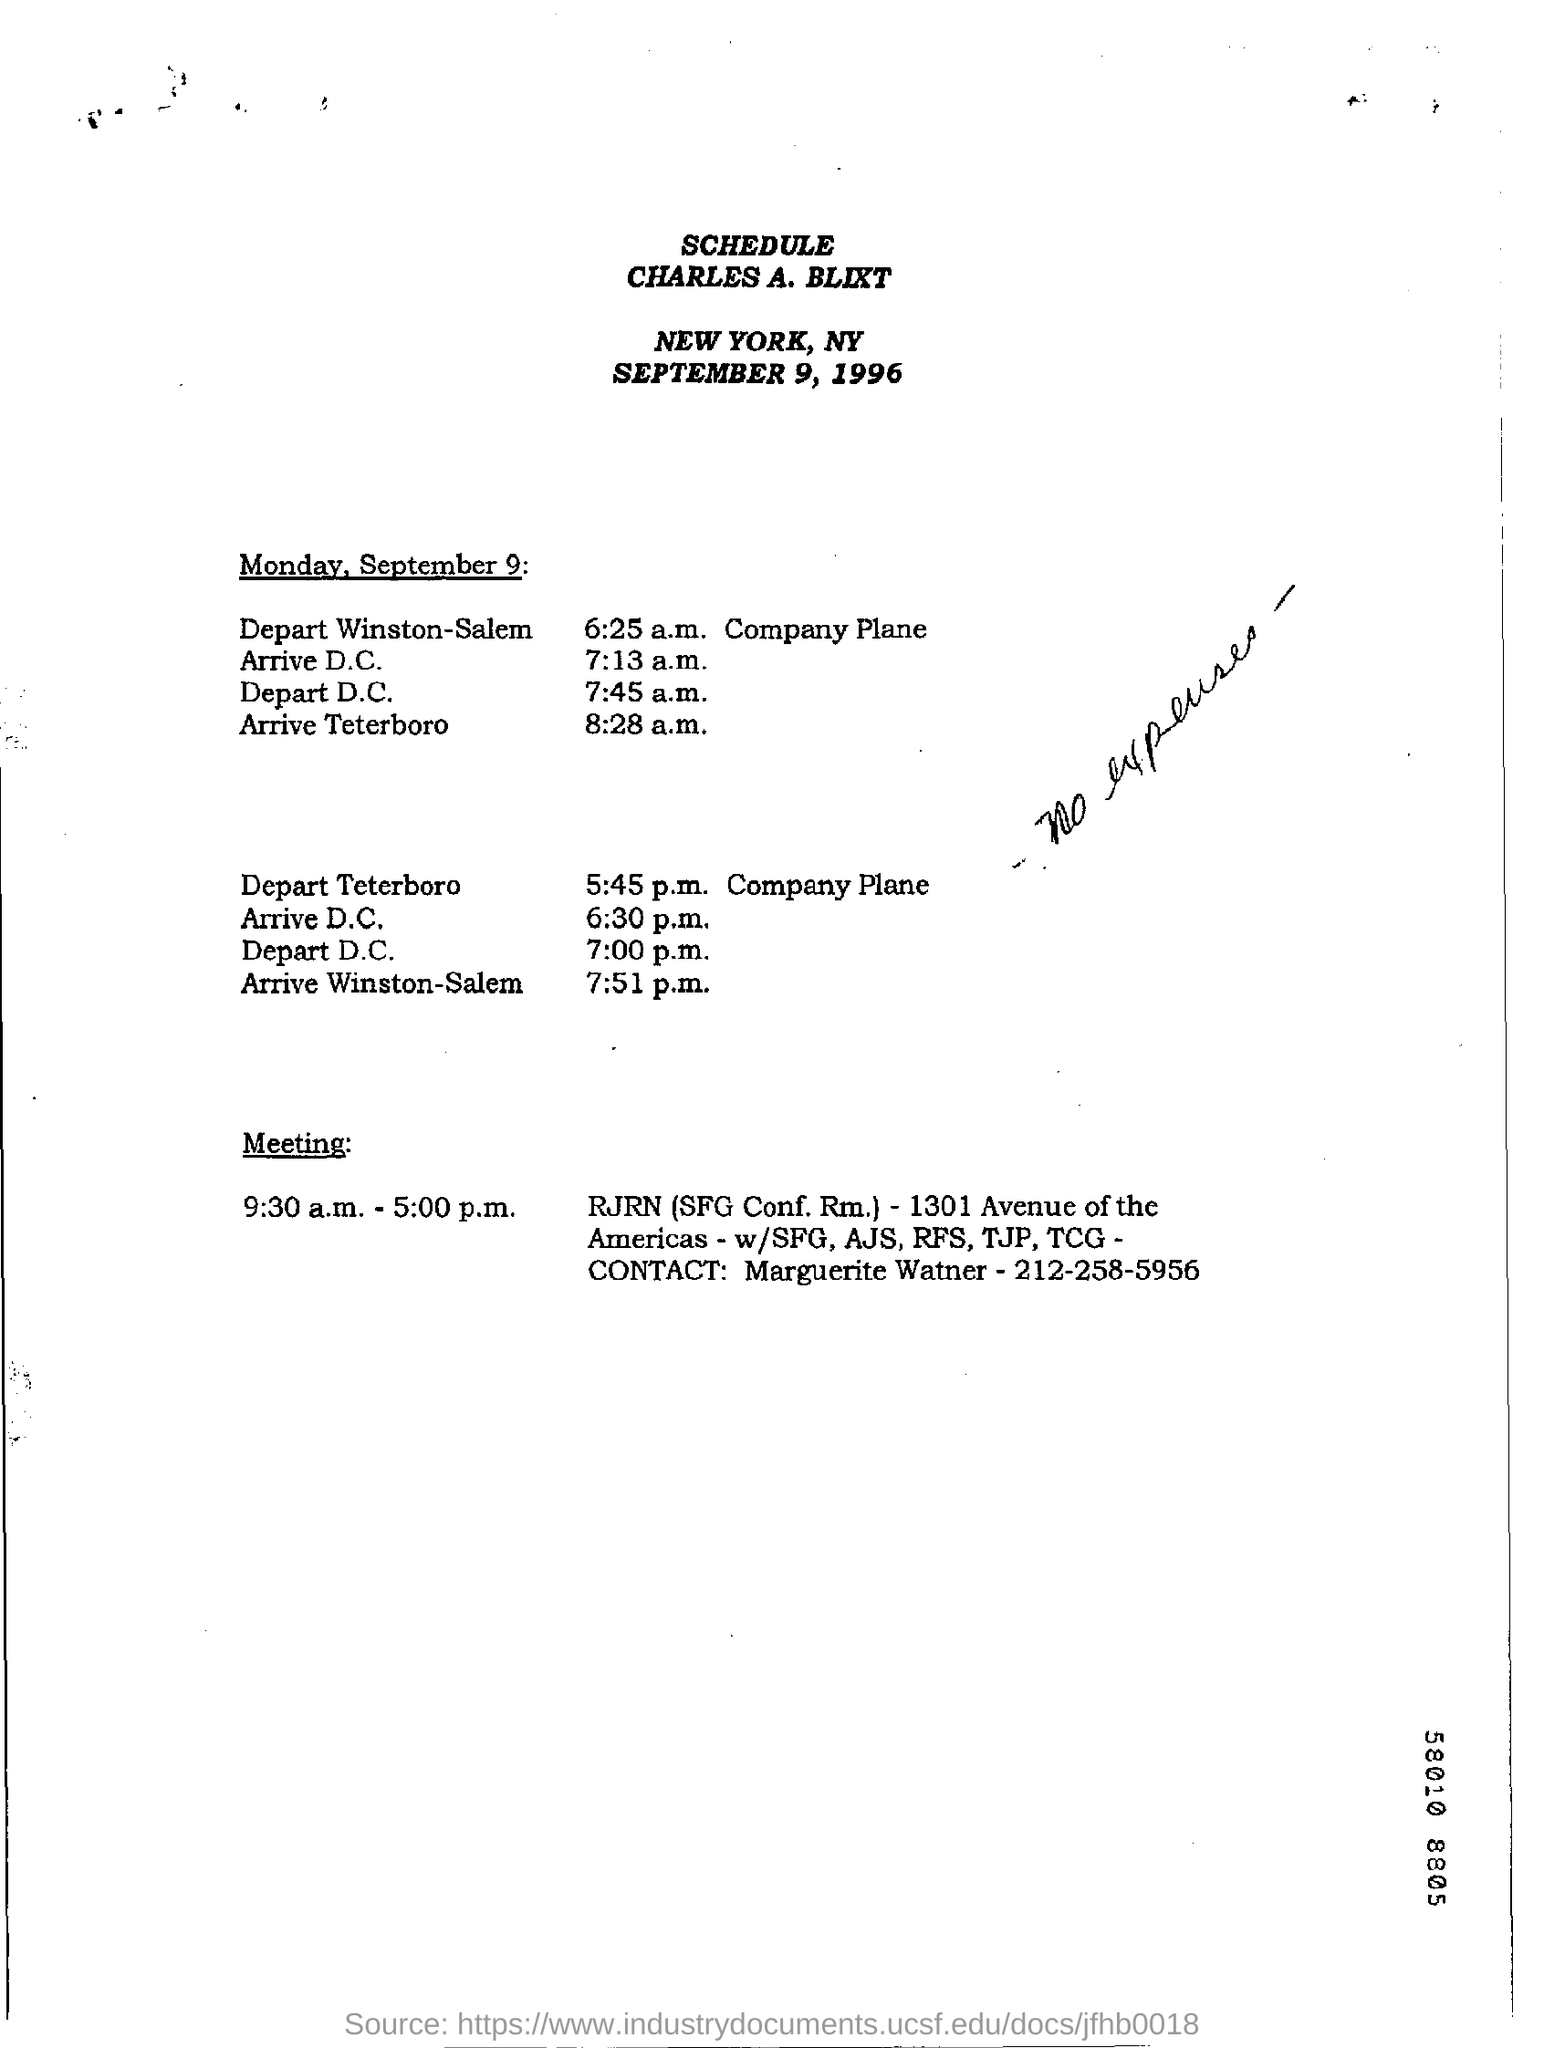Indicate a few pertinent items in this graphic. Marguerite Watner's contact number is 212-258-5956. The document contains handwriting that reads 'no expenses' followed by... The name that appears at the top of the schedule is Charles A. Bliszt. The schedule is dated September 9, 1996. 